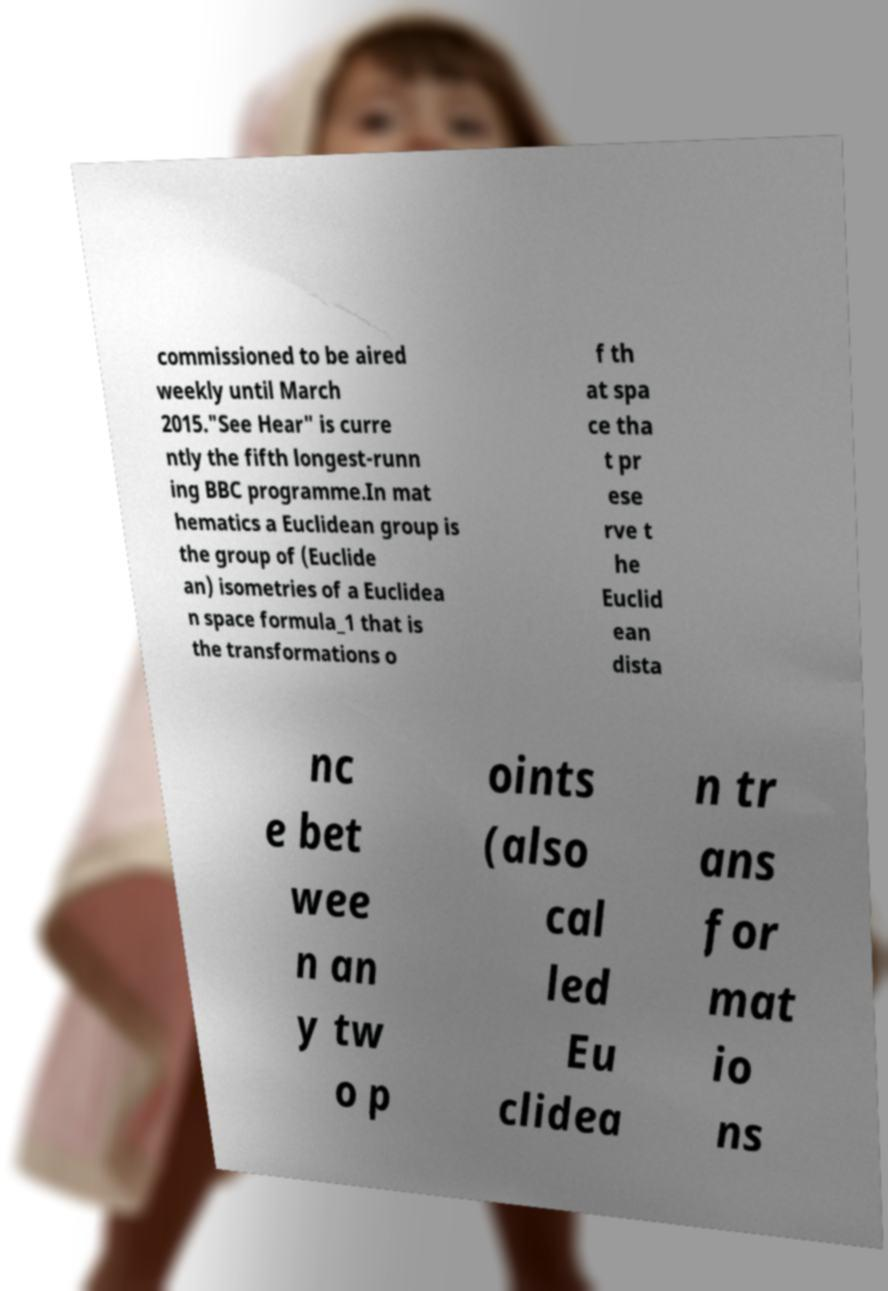Could you extract and type out the text from this image? commissioned to be aired weekly until March 2015."See Hear" is curre ntly the fifth longest-runn ing BBC programme.In mat hematics a Euclidean group is the group of (Euclide an) isometries of a Euclidea n space formula_1 that is the transformations o f th at spa ce tha t pr ese rve t he Euclid ean dista nc e bet wee n an y tw o p oints (also cal led Eu clidea n tr ans for mat io ns 